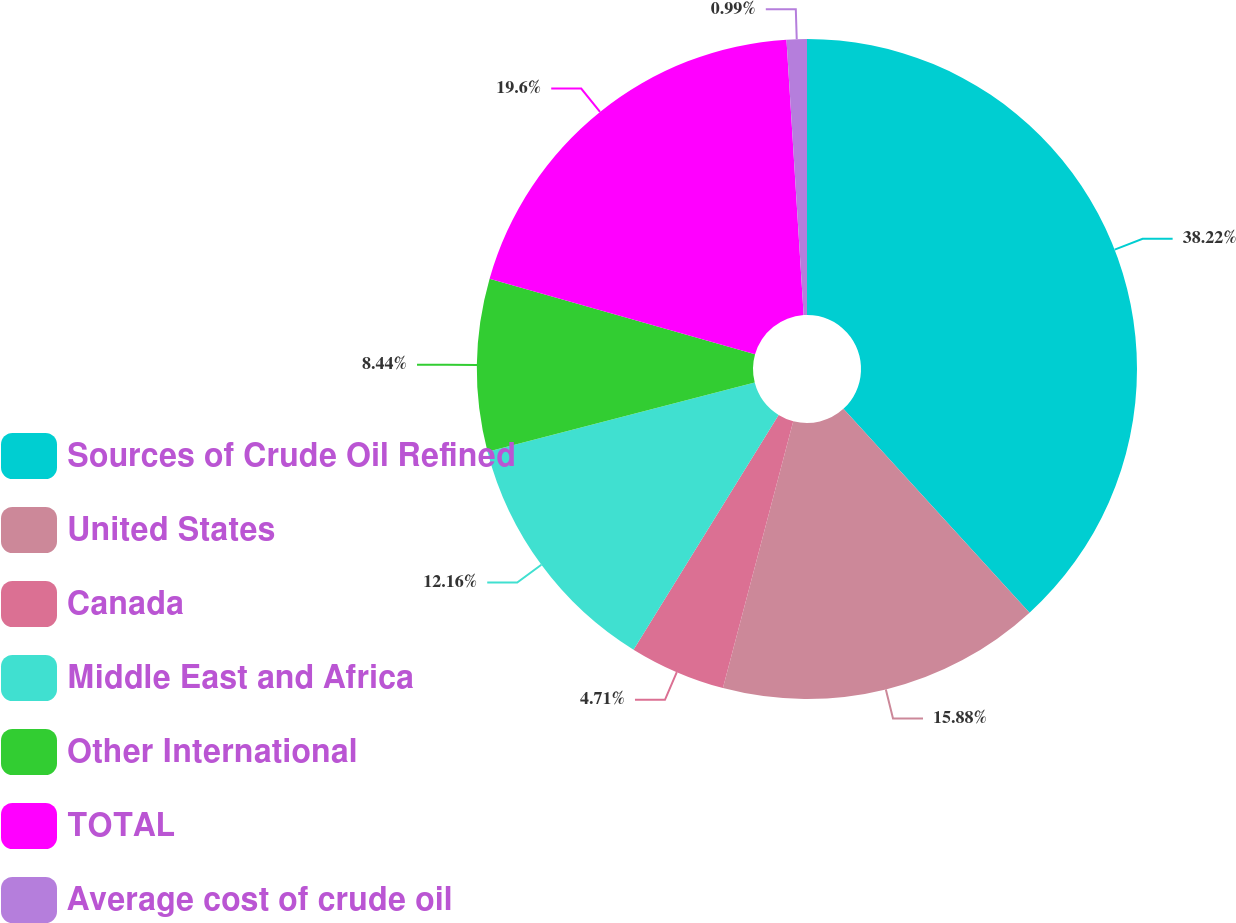<chart> <loc_0><loc_0><loc_500><loc_500><pie_chart><fcel>Sources of Crude Oil Refined<fcel>United States<fcel>Canada<fcel>Middle East and Africa<fcel>Other International<fcel>TOTAL<fcel>Average cost of crude oil<nl><fcel>38.22%<fcel>15.88%<fcel>4.71%<fcel>12.16%<fcel>8.44%<fcel>19.6%<fcel>0.99%<nl></chart> 